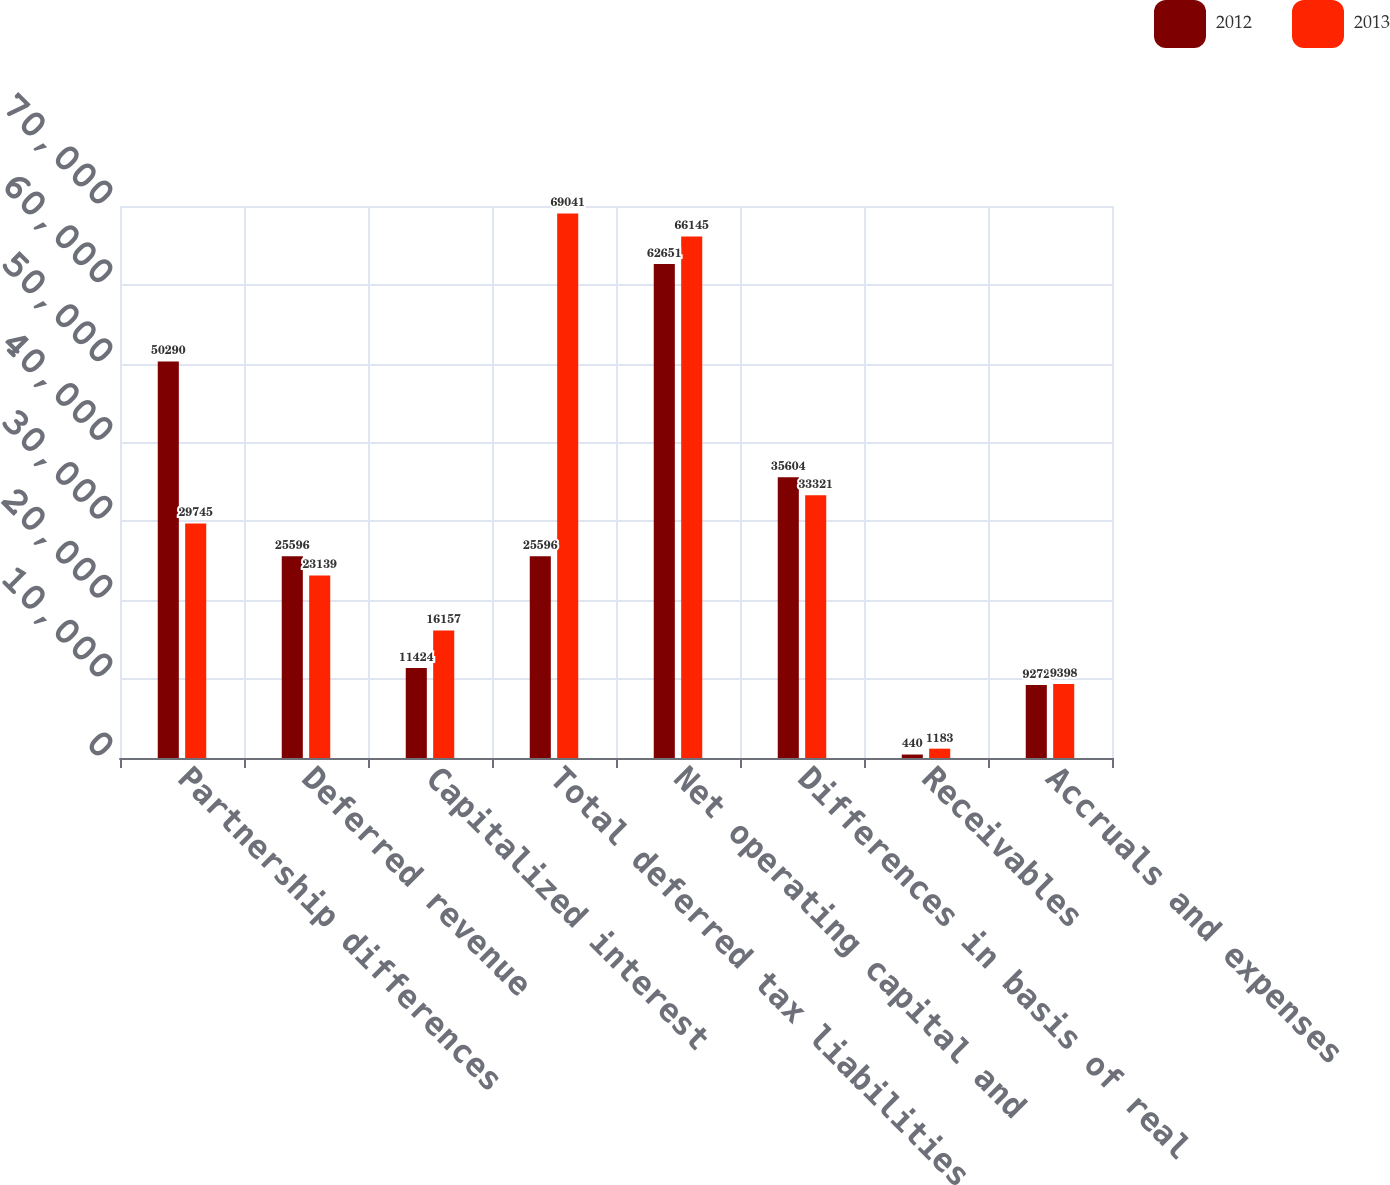Convert chart. <chart><loc_0><loc_0><loc_500><loc_500><stacked_bar_chart><ecel><fcel>Partnership differences<fcel>Deferred revenue<fcel>Capitalized interest<fcel>Total deferred tax liabilities<fcel>Net operating capital and<fcel>Differences in basis of real<fcel>Receivables<fcel>Accruals and expenses<nl><fcel>2012<fcel>50290<fcel>25596<fcel>11424<fcel>25596<fcel>62651<fcel>35604<fcel>440<fcel>9272<nl><fcel>2013<fcel>29745<fcel>23139<fcel>16157<fcel>69041<fcel>66145<fcel>33321<fcel>1183<fcel>9398<nl></chart> 